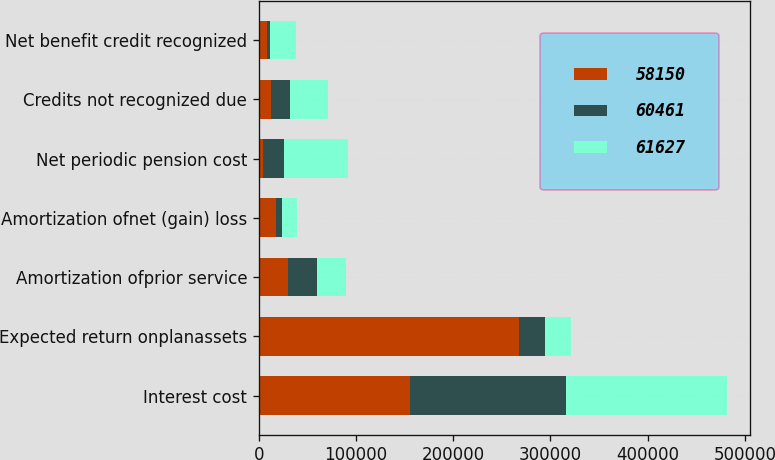Convert chart. <chart><loc_0><loc_0><loc_500><loc_500><stacked_bar_chart><ecel><fcel>Interest cost<fcel>Expected return onplanassets<fcel>Amortization ofprior service<fcel>Amortization ofnet (gain) loss<fcel>Net periodic pension cost<fcel>Credits not recognized due<fcel>Net benefit credit recognized<nl><fcel>58150<fcel>155413<fcel>268065<fcel>29696<fcel>17353<fcel>3976<fcel>12637<fcel>8661<nl><fcel>60461<fcel>160985<fcel>26611<fcel>30035<fcel>6819<fcel>21764<fcel>19368<fcel>2396<nl><fcel>61627<fcel>165361<fcel>26611<fcel>30009<fcel>15207<fcel>65578<fcel>38967<fcel>26611<nl></chart> 